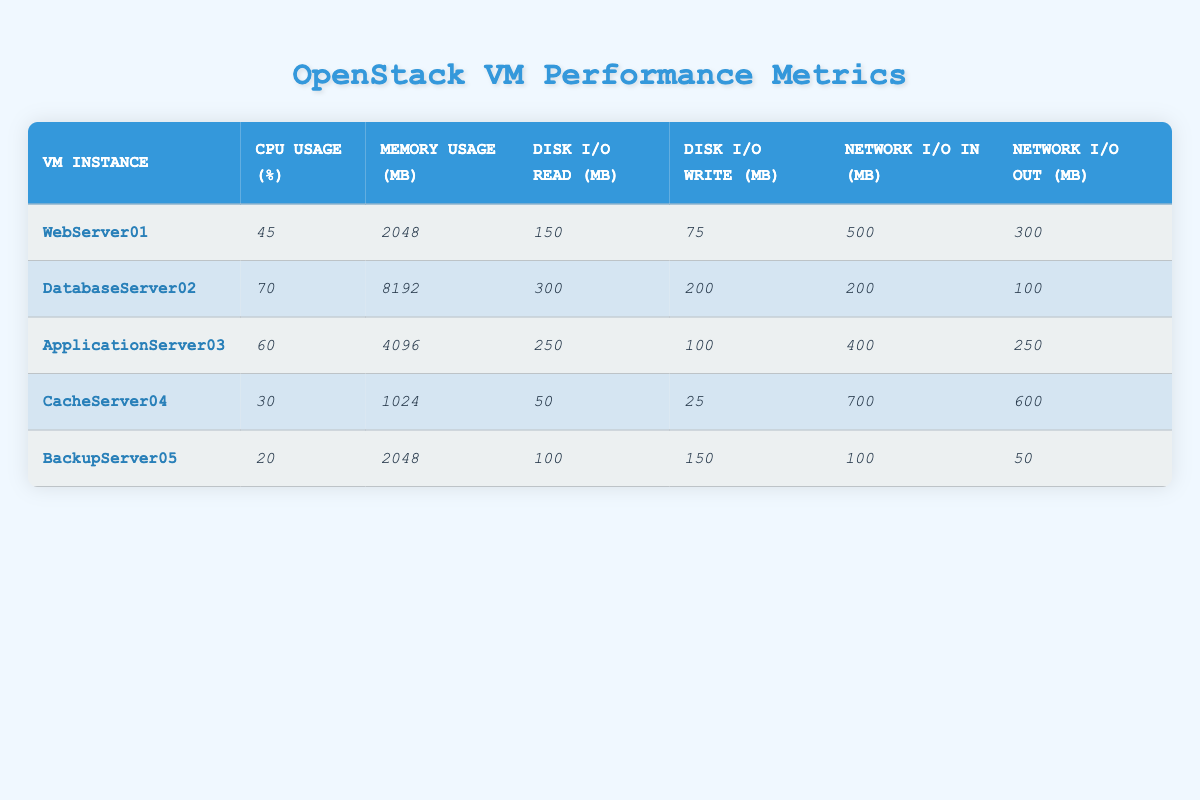What is the CPU usage percentage of CacheServer04? By looking at the row for CacheServer04 in the table, the CPU usage percentage is clearly listed as 30%.
Answer: 30% What is the memory usage in megabytes of DatabaseServer02? In the table, for DatabaseServer02, the memory usage is specified as 8192 MB.
Answer: 8192 MB Which VM instance has the highest network I/O out (MB)? Examining the "Network I/O Out" column, CacheServer04 has the highest value of 600 MB.
Answer: CacheServer04 What is the total disk I/O read for all VM instances combined? The disk I/O read values are 150 + 300 + 250 + 50 + 100 = 850 MB.
Answer: 850 MB What VM instance has the lowest CPU usage? The CPU usage for the VM instances shows BackupServer05 with 20% as the lowest value.
Answer: BackupServer05 Is the memory usage of ApplicationServer03 greater than 5000 MB? The memory usage for ApplicationServer03 is 4096 MB, which is less than 5000 MB.
Answer: No What is the average network I/O in for the listed VMs? Adding the "Network I/O In" values: 500 + 200 + 400 + 700 + 100 = 1900 MB. Dividing this sum by 5 gives an average of 380 MB.
Answer: 380 MB Which server has the highest disk I/O write? Looking at the "Disk I/O Write" column, DatabaseServer02 has the highest value of 200 MB.
Answer: DatabaseServer02 What is the difference between the highest and lowest CPU usage percentages? The highest CPU usage is 70% (DatabaseServer02) and the lowest is 20% (BackupServer05). The difference is 70 - 20 = 50%.
Answer: 50% Which VM has the most network I/O in combined with network I/O out? Summing the values, CacheServer04 has 700 + 600 = 1300 MB, which is higher than any other VM.
Answer: CacheServer04 